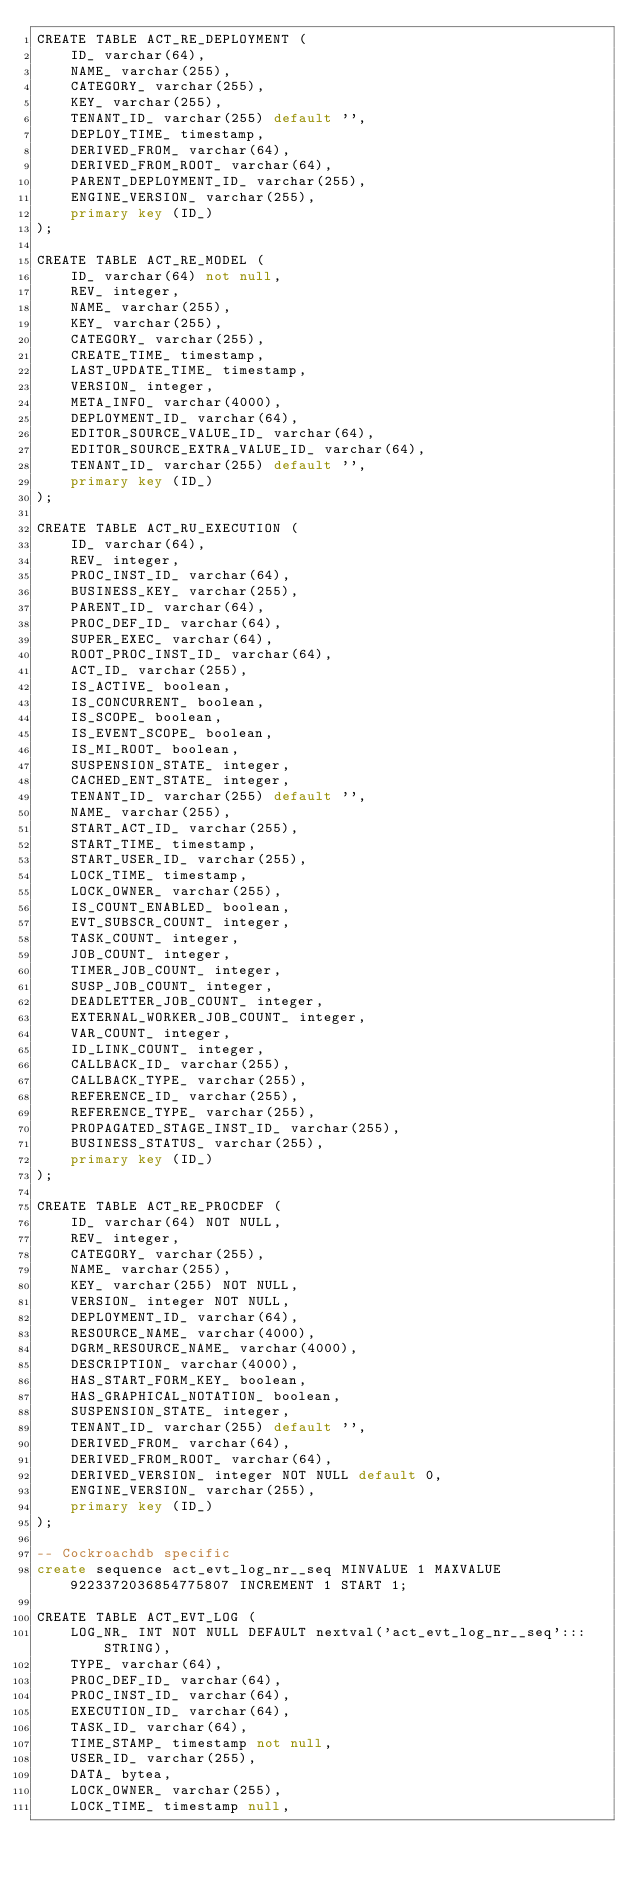Convert code to text. <code><loc_0><loc_0><loc_500><loc_500><_SQL_>CREATE TABLE ACT_RE_DEPLOYMENT (
    ID_ varchar(64),
    NAME_ varchar(255),
    CATEGORY_ varchar(255),
    KEY_ varchar(255),
    TENANT_ID_ varchar(255) default '',
    DEPLOY_TIME_ timestamp,
    DERIVED_FROM_ varchar(64),
    DERIVED_FROM_ROOT_ varchar(64),
    PARENT_DEPLOYMENT_ID_ varchar(255),
    ENGINE_VERSION_ varchar(255),
    primary key (ID_)
);

CREATE TABLE ACT_RE_MODEL (
    ID_ varchar(64) not null,
    REV_ integer,
    NAME_ varchar(255),
    KEY_ varchar(255),
    CATEGORY_ varchar(255),
    CREATE_TIME_ timestamp,
    LAST_UPDATE_TIME_ timestamp,
    VERSION_ integer,
    META_INFO_ varchar(4000),
    DEPLOYMENT_ID_ varchar(64),
    EDITOR_SOURCE_VALUE_ID_ varchar(64),
    EDITOR_SOURCE_EXTRA_VALUE_ID_ varchar(64),
    TENANT_ID_ varchar(255) default '',
    primary key (ID_)
);

CREATE TABLE ACT_RU_EXECUTION (
    ID_ varchar(64),
    REV_ integer,
    PROC_INST_ID_ varchar(64),
    BUSINESS_KEY_ varchar(255),
    PARENT_ID_ varchar(64),
    PROC_DEF_ID_ varchar(64),
    SUPER_EXEC_ varchar(64),
    ROOT_PROC_INST_ID_ varchar(64),
    ACT_ID_ varchar(255),
    IS_ACTIVE_ boolean,
    IS_CONCURRENT_ boolean,
    IS_SCOPE_ boolean,
    IS_EVENT_SCOPE_ boolean,
    IS_MI_ROOT_ boolean,
    SUSPENSION_STATE_ integer,
    CACHED_ENT_STATE_ integer,
    TENANT_ID_ varchar(255) default '',
    NAME_ varchar(255),
    START_ACT_ID_ varchar(255),
    START_TIME_ timestamp,
    START_USER_ID_ varchar(255),
    LOCK_TIME_ timestamp,
    LOCK_OWNER_ varchar(255),
    IS_COUNT_ENABLED_ boolean,
    EVT_SUBSCR_COUNT_ integer, 
    TASK_COUNT_ integer, 
    JOB_COUNT_ integer, 
    TIMER_JOB_COUNT_ integer,
    SUSP_JOB_COUNT_ integer,
    DEADLETTER_JOB_COUNT_ integer,
    EXTERNAL_WORKER_JOB_COUNT_ integer,
    VAR_COUNT_ integer, 
    ID_LINK_COUNT_ integer,
    CALLBACK_ID_ varchar(255),
    CALLBACK_TYPE_ varchar(255),
    REFERENCE_ID_ varchar(255),
    REFERENCE_TYPE_ varchar(255),
    PROPAGATED_STAGE_INST_ID_ varchar(255),
    BUSINESS_STATUS_ varchar(255),
    primary key (ID_)
);

CREATE TABLE ACT_RE_PROCDEF (
    ID_ varchar(64) NOT NULL,
    REV_ integer,
    CATEGORY_ varchar(255),
    NAME_ varchar(255),
    KEY_ varchar(255) NOT NULL,
    VERSION_ integer NOT NULL,
    DEPLOYMENT_ID_ varchar(64),
    RESOURCE_NAME_ varchar(4000),
    DGRM_RESOURCE_NAME_ varchar(4000),
    DESCRIPTION_ varchar(4000),
    HAS_START_FORM_KEY_ boolean,
    HAS_GRAPHICAL_NOTATION_ boolean,
    SUSPENSION_STATE_ integer,
    TENANT_ID_ varchar(255) default '',
    DERIVED_FROM_ varchar(64),
    DERIVED_FROM_ROOT_ varchar(64),
    DERIVED_VERSION_ integer NOT NULL default 0,
    ENGINE_VERSION_ varchar(255),
    primary key (ID_)
);

-- Cockroachdb specific
create sequence act_evt_log_nr__seq MINVALUE 1 MAXVALUE 9223372036854775807 INCREMENT 1 START 1;

CREATE TABLE ACT_EVT_LOG (
    LOG_NR_ INT NOT NULL DEFAULT nextval('act_evt_log_nr__seq':::STRING),
    TYPE_ varchar(64),
    PROC_DEF_ID_ varchar(64),
    PROC_INST_ID_ varchar(64),
    EXECUTION_ID_ varchar(64),
    TASK_ID_ varchar(64),
    TIME_STAMP_ timestamp not null,
    USER_ID_ varchar(255),
    DATA_ bytea,
    LOCK_OWNER_ varchar(255),
    LOCK_TIME_ timestamp null,</code> 